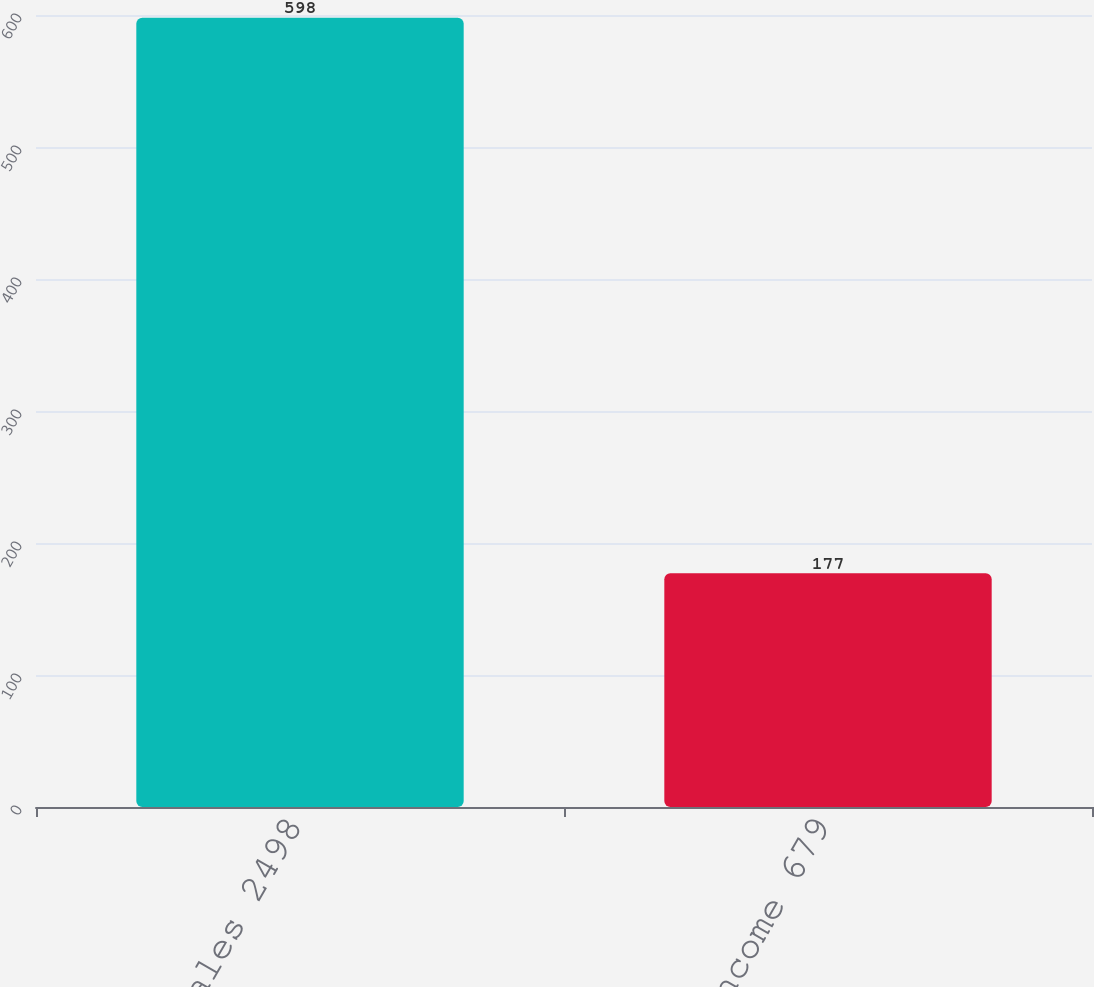<chart> <loc_0><loc_0><loc_500><loc_500><bar_chart><fcel>Net sales 2498<fcel>Operating income 679<nl><fcel>598<fcel>177<nl></chart> 